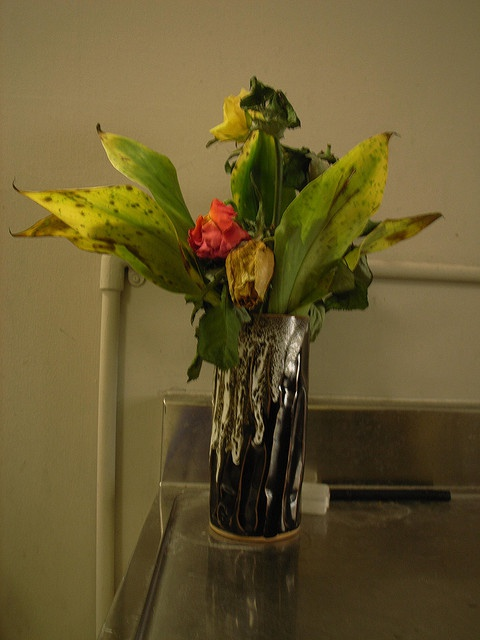Describe the objects in this image and their specific colors. I can see a vase in olive, black, and gray tones in this image. 